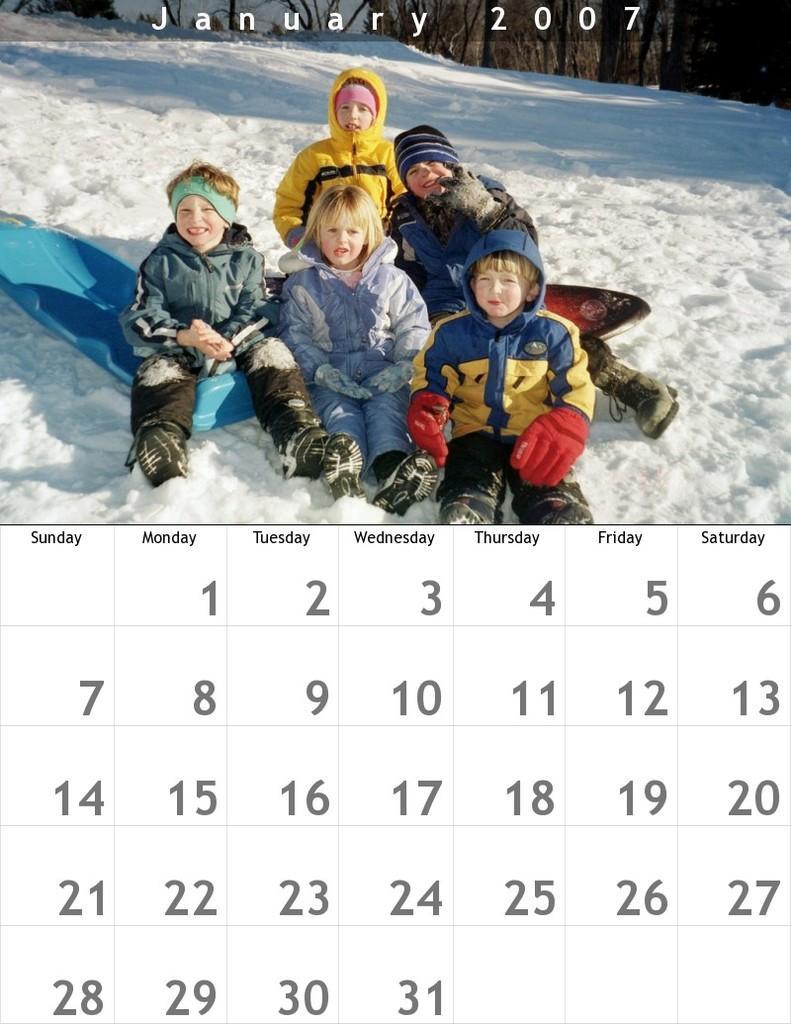Please provide a concise description of this image. In this image I can see the calendar. To the top I can see a picture in which I can see few persons and some snow on the ground. 